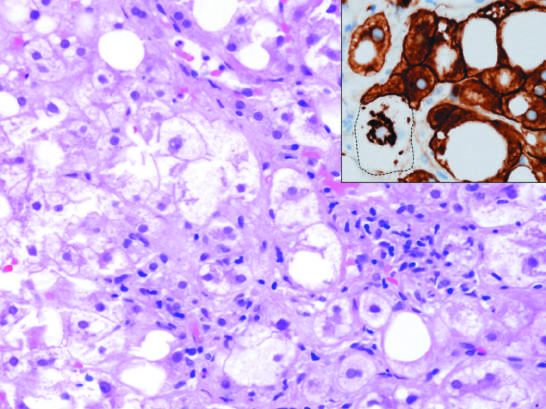what is hepatocyte injury in fatty liver disease associated with?
Answer the question using a single word or phrase. Chronic alcohol use 